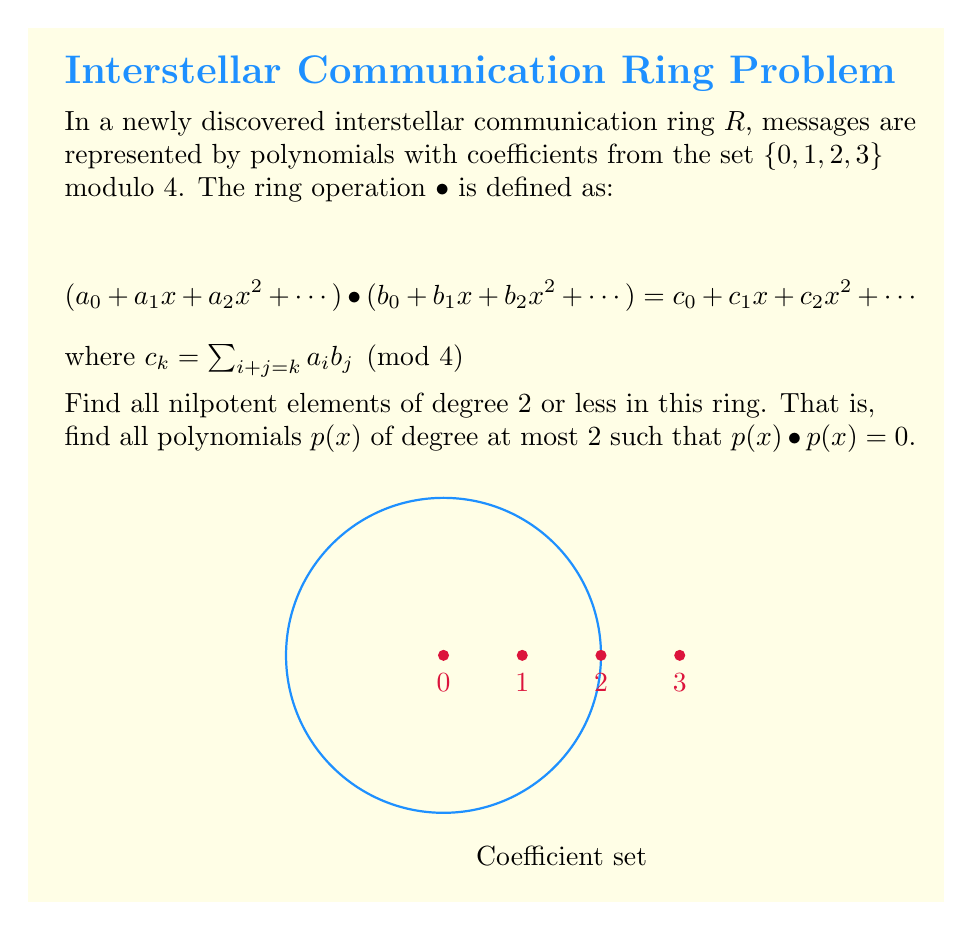Solve this math problem. Let's approach this step-by-step:

1) The general form of a polynomial of degree 2 or less in this ring is:
   $p(x) = a + bx + cx^2$, where $a, b, c \in \{0, 1, 2, 3\}$

2) We need to find all such polynomials where $p(x) • p(x) = 0$

3) Let's expand $p(x) • p(x)$:
   $(a + bx + cx^2) • (a + bx + cx^2) = a^2 + (2ab)x + (2ac + b^2)x^2 + (2bc)x^3 + c^2x^4$

4) For this to be zero, all coefficients must be 0 mod 4:
   $a^2 \equiv 0 \pmod{4}$
   $2ab \equiv 0 \pmod{4}$
   $2ac + b^2 \equiv 0 \pmod{4}$
   $2bc \equiv 0 \pmod{4}$
   $c^2 \equiv 0 \pmod{4}$

5) From the first and last equations, we can deduce that $a$ and $c$ must be either 0 or 2.

6) If $a = 2$, then from the second equation, $b$ must be even (0 or 2).

7) If $c = 2$, then from the fourth equation, $b$ must be even (0 or 2).

8) The third equation is always satisfied when $a$, $b$, and $c$ are even.

9) Therefore, the nilpotent elements are:
   $0$, $2$, $2x$, $2x^2$, $2 + 2x$, $2 + 2x^2$, $2x + 2x^2$, $2 + 2x + 2x^2$
Answer: $\{0, 2, 2x, 2x^2, 2 + 2x, 2 + 2x^2, 2x + 2x^2, 2 + 2x + 2x^2\}$ 